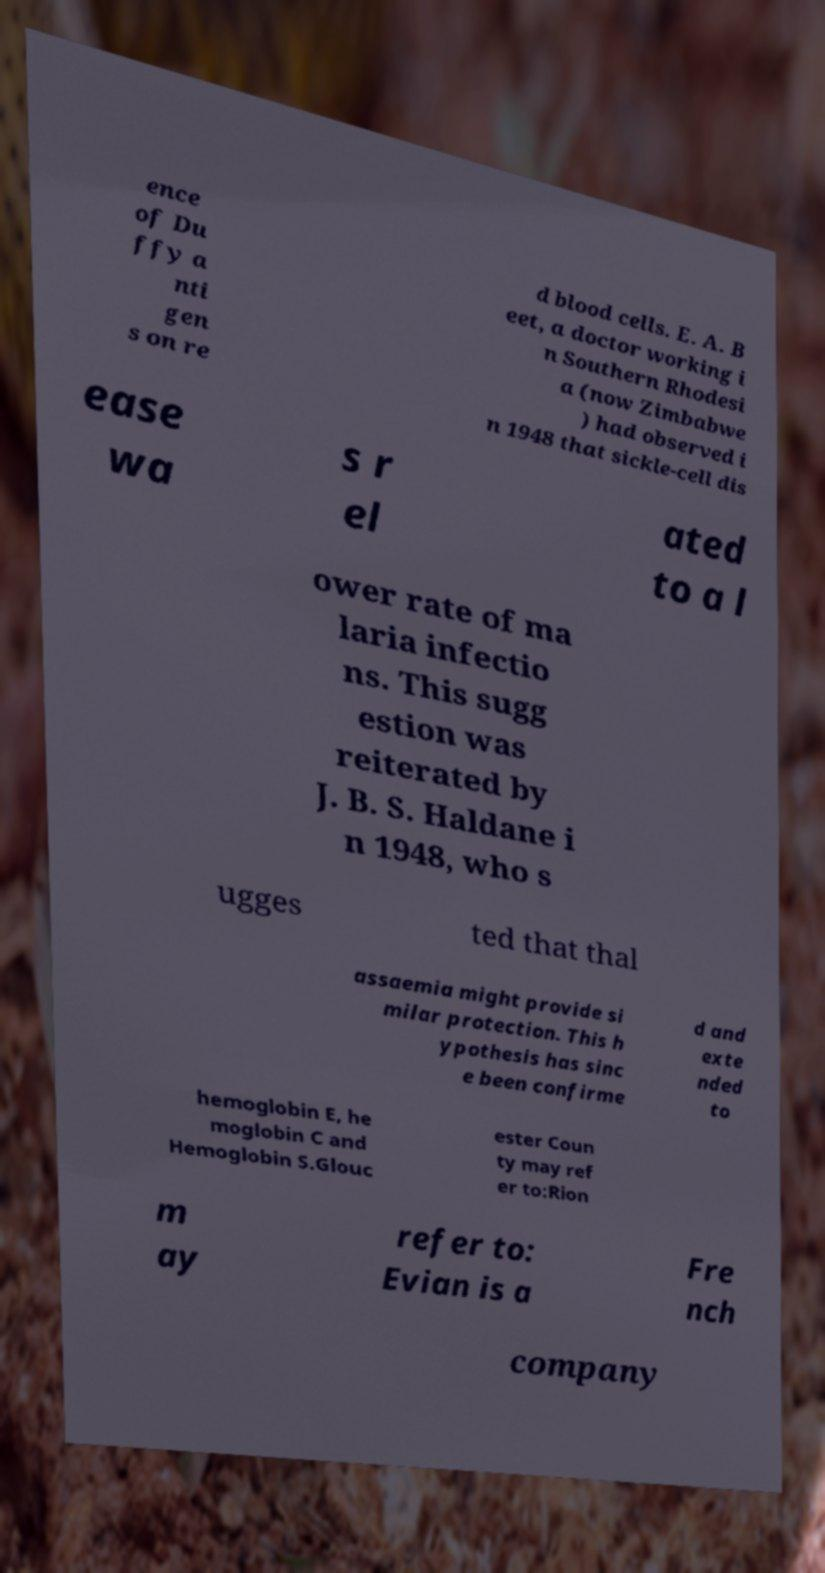Please read and relay the text visible in this image. What does it say? ence of Du ffy a nti gen s on re d blood cells. E. A. B eet, a doctor working i n Southern Rhodesi a (now Zimbabwe ) had observed i n 1948 that sickle-cell dis ease wa s r el ated to a l ower rate of ma laria infectio ns. This sugg estion was reiterated by J. B. S. Haldane i n 1948, who s ugges ted that thal assaemia might provide si milar protection. This h ypothesis has sinc e been confirme d and exte nded to hemoglobin E, he moglobin C and Hemoglobin S.Glouc ester Coun ty may ref er to:Rion m ay refer to: Evian is a Fre nch company 